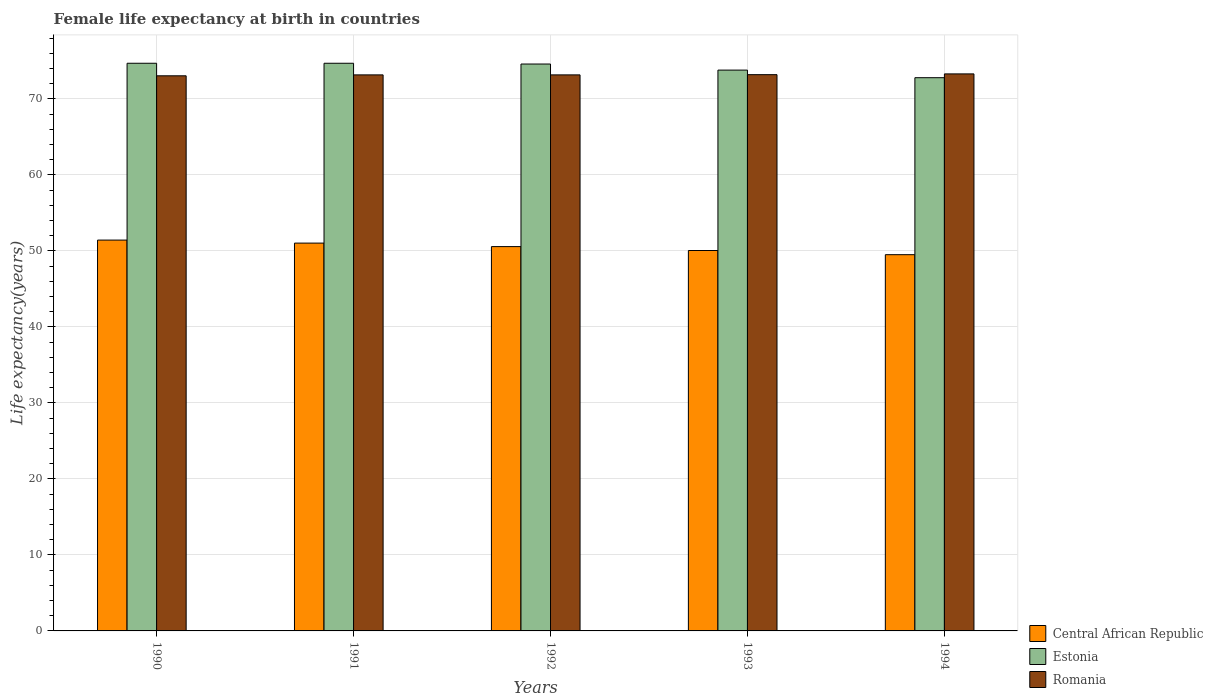Are the number of bars on each tick of the X-axis equal?
Ensure brevity in your answer.  Yes. How many bars are there on the 4th tick from the left?
Provide a short and direct response. 3. What is the label of the 3rd group of bars from the left?
Provide a succinct answer. 1992. What is the female life expectancy at birth in Central African Republic in 1993?
Offer a terse response. 50.06. Across all years, what is the maximum female life expectancy at birth in Central African Republic?
Keep it short and to the point. 51.43. Across all years, what is the minimum female life expectancy at birth in Central African Republic?
Provide a succinct answer. 49.51. What is the total female life expectancy at birth in Estonia in the graph?
Make the answer very short. 370.6. What is the difference between the female life expectancy at birth in Central African Republic in 1991 and that in 1993?
Your response must be concise. 0.97. What is the difference between the female life expectancy at birth in Estonia in 1992 and the female life expectancy at birth in Romania in 1991?
Make the answer very short. 1.43. What is the average female life expectancy at birth in Romania per year?
Offer a very short reply. 73.18. In the year 1993, what is the difference between the female life expectancy at birth in Estonia and female life expectancy at birth in Romania?
Your response must be concise. 0.6. What is the ratio of the female life expectancy at birth in Central African Republic in 1991 to that in 1994?
Offer a very short reply. 1.03. Is the difference between the female life expectancy at birth in Estonia in 1991 and 1992 greater than the difference between the female life expectancy at birth in Romania in 1991 and 1992?
Provide a succinct answer. Yes. What is the difference between the highest and the lowest female life expectancy at birth in Romania?
Your answer should be very brief. 0.25. In how many years, is the female life expectancy at birth in Central African Republic greater than the average female life expectancy at birth in Central African Republic taken over all years?
Offer a very short reply. 3. Is the sum of the female life expectancy at birth in Central African Republic in 1990 and 1992 greater than the maximum female life expectancy at birth in Estonia across all years?
Offer a very short reply. Yes. What does the 3rd bar from the left in 1994 represents?
Your answer should be very brief. Romania. What does the 1st bar from the right in 1990 represents?
Offer a very short reply. Romania. Are all the bars in the graph horizontal?
Your response must be concise. No. What is the difference between two consecutive major ticks on the Y-axis?
Your response must be concise. 10. Are the values on the major ticks of Y-axis written in scientific E-notation?
Your answer should be compact. No. Does the graph contain any zero values?
Keep it short and to the point. No. Does the graph contain grids?
Keep it short and to the point. Yes. Where does the legend appear in the graph?
Keep it short and to the point. Bottom right. How many legend labels are there?
Offer a terse response. 3. What is the title of the graph?
Provide a succinct answer. Female life expectancy at birth in countries. Does "Oman" appear as one of the legend labels in the graph?
Ensure brevity in your answer.  No. What is the label or title of the Y-axis?
Keep it short and to the point. Life expectancy(years). What is the Life expectancy(years) of Central African Republic in 1990?
Make the answer very short. 51.43. What is the Life expectancy(years) in Estonia in 1990?
Your answer should be compact. 74.7. What is the Life expectancy(years) of Romania in 1990?
Offer a terse response. 73.05. What is the Life expectancy(years) in Central African Republic in 1991?
Provide a succinct answer. 51.03. What is the Life expectancy(years) in Estonia in 1991?
Offer a terse response. 74.7. What is the Life expectancy(years) in Romania in 1991?
Ensure brevity in your answer.  73.17. What is the Life expectancy(years) of Central African Republic in 1992?
Offer a very short reply. 50.57. What is the Life expectancy(years) of Estonia in 1992?
Keep it short and to the point. 74.6. What is the Life expectancy(years) in Romania in 1992?
Provide a short and direct response. 73.17. What is the Life expectancy(years) in Central African Republic in 1993?
Your answer should be compact. 50.06. What is the Life expectancy(years) in Estonia in 1993?
Offer a terse response. 73.8. What is the Life expectancy(years) of Romania in 1993?
Keep it short and to the point. 73.2. What is the Life expectancy(years) of Central African Republic in 1994?
Offer a terse response. 49.51. What is the Life expectancy(years) in Estonia in 1994?
Your answer should be compact. 72.8. What is the Life expectancy(years) of Romania in 1994?
Provide a succinct answer. 73.3. Across all years, what is the maximum Life expectancy(years) of Central African Republic?
Make the answer very short. 51.43. Across all years, what is the maximum Life expectancy(years) in Estonia?
Keep it short and to the point. 74.7. Across all years, what is the maximum Life expectancy(years) in Romania?
Your response must be concise. 73.3. Across all years, what is the minimum Life expectancy(years) of Central African Republic?
Your answer should be very brief. 49.51. Across all years, what is the minimum Life expectancy(years) of Estonia?
Provide a succinct answer. 72.8. Across all years, what is the minimum Life expectancy(years) in Romania?
Your answer should be compact. 73.05. What is the total Life expectancy(years) in Central African Republic in the graph?
Keep it short and to the point. 252.61. What is the total Life expectancy(years) of Estonia in the graph?
Offer a very short reply. 370.6. What is the total Life expectancy(years) in Romania in the graph?
Your answer should be very brief. 365.89. What is the difference between the Life expectancy(years) in Central African Republic in 1990 and that in 1991?
Your response must be concise. 0.4. What is the difference between the Life expectancy(years) in Romania in 1990 and that in 1991?
Ensure brevity in your answer.  -0.12. What is the difference between the Life expectancy(years) of Central African Republic in 1990 and that in 1992?
Offer a very short reply. 0.86. What is the difference between the Life expectancy(years) of Romania in 1990 and that in 1992?
Provide a succinct answer. -0.12. What is the difference between the Life expectancy(years) of Central African Republic in 1990 and that in 1993?
Your answer should be compact. 1.37. What is the difference between the Life expectancy(years) of Estonia in 1990 and that in 1993?
Offer a very short reply. 0.9. What is the difference between the Life expectancy(years) of Central African Republic in 1990 and that in 1994?
Provide a short and direct response. 1.92. What is the difference between the Life expectancy(years) in Estonia in 1990 and that in 1994?
Make the answer very short. 1.9. What is the difference between the Life expectancy(years) of Romania in 1990 and that in 1994?
Your answer should be compact. -0.25. What is the difference between the Life expectancy(years) of Central African Republic in 1991 and that in 1992?
Offer a terse response. 0.46. What is the difference between the Life expectancy(years) in Estonia in 1991 and that in 1992?
Make the answer very short. 0.1. What is the difference between the Life expectancy(years) in Romania in 1991 and that in 1992?
Ensure brevity in your answer.  0. What is the difference between the Life expectancy(years) of Central African Republic in 1991 and that in 1993?
Your response must be concise. 0.97. What is the difference between the Life expectancy(years) in Romania in 1991 and that in 1993?
Your response must be concise. -0.03. What is the difference between the Life expectancy(years) in Central African Republic in 1991 and that in 1994?
Provide a short and direct response. 1.52. What is the difference between the Life expectancy(years) of Romania in 1991 and that in 1994?
Ensure brevity in your answer.  -0.13. What is the difference between the Life expectancy(years) of Central African Republic in 1992 and that in 1993?
Your response must be concise. 0.51. What is the difference between the Life expectancy(years) of Romania in 1992 and that in 1993?
Offer a terse response. -0.03. What is the difference between the Life expectancy(years) of Central African Republic in 1992 and that in 1994?
Offer a terse response. 1.06. What is the difference between the Life expectancy(years) of Romania in 1992 and that in 1994?
Offer a terse response. -0.13. What is the difference between the Life expectancy(years) of Central African Republic in 1993 and that in 1994?
Provide a short and direct response. 0.55. What is the difference between the Life expectancy(years) of Estonia in 1993 and that in 1994?
Make the answer very short. 1. What is the difference between the Life expectancy(years) in Romania in 1993 and that in 1994?
Offer a terse response. -0.1. What is the difference between the Life expectancy(years) of Central African Republic in 1990 and the Life expectancy(years) of Estonia in 1991?
Your answer should be very brief. -23.27. What is the difference between the Life expectancy(years) of Central African Republic in 1990 and the Life expectancy(years) of Romania in 1991?
Your response must be concise. -21.74. What is the difference between the Life expectancy(years) of Estonia in 1990 and the Life expectancy(years) of Romania in 1991?
Your answer should be compact. 1.53. What is the difference between the Life expectancy(years) of Central African Republic in 1990 and the Life expectancy(years) of Estonia in 1992?
Ensure brevity in your answer.  -23.17. What is the difference between the Life expectancy(years) in Central African Republic in 1990 and the Life expectancy(years) in Romania in 1992?
Make the answer very short. -21.74. What is the difference between the Life expectancy(years) in Estonia in 1990 and the Life expectancy(years) in Romania in 1992?
Your response must be concise. 1.53. What is the difference between the Life expectancy(years) in Central African Republic in 1990 and the Life expectancy(years) in Estonia in 1993?
Your answer should be very brief. -22.37. What is the difference between the Life expectancy(years) in Central African Republic in 1990 and the Life expectancy(years) in Romania in 1993?
Your answer should be compact. -21.77. What is the difference between the Life expectancy(years) in Estonia in 1990 and the Life expectancy(years) in Romania in 1993?
Give a very brief answer. 1.5. What is the difference between the Life expectancy(years) of Central African Republic in 1990 and the Life expectancy(years) of Estonia in 1994?
Ensure brevity in your answer.  -21.37. What is the difference between the Life expectancy(years) in Central African Republic in 1990 and the Life expectancy(years) in Romania in 1994?
Provide a succinct answer. -21.87. What is the difference between the Life expectancy(years) in Estonia in 1990 and the Life expectancy(years) in Romania in 1994?
Ensure brevity in your answer.  1.4. What is the difference between the Life expectancy(years) in Central African Republic in 1991 and the Life expectancy(years) in Estonia in 1992?
Ensure brevity in your answer.  -23.57. What is the difference between the Life expectancy(years) of Central African Republic in 1991 and the Life expectancy(years) of Romania in 1992?
Offer a terse response. -22.14. What is the difference between the Life expectancy(years) in Estonia in 1991 and the Life expectancy(years) in Romania in 1992?
Make the answer very short. 1.53. What is the difference between the Life expectancy(years) in Central African Republic in 1991 and the Life expectancy(years) in Estonia in 1993?
Ensure brevity in your answer.  -22.77. What is the difference between the Life expectancy(years) in Central African Republic in 1991 and the Life expectancy(years) in Romania in 1993?
Provide a short and direct response. -22.17. What is the difference between the Life expectancy(years) of Estonia in 1991 and the Life expectancy(years) of Romania in 1993?
Provide a succinct answer. 1.5. What is the difference between the Life expectancy(years) of Central African Republic in 1991 and the Life expectancy(years) of Estonia in 1994?
Provide a succinct answer. -21.77. What is the difference between the Life expectancy(years) of Central African Republic in 1991 and the Life expectancy(years) of Romania in 1994?
Make the answer very short. -22.27. What is the difference between the Life expectancy(years) of Central African Republic in 1992 and the Life expectancy(years) of Estonia in 1993?
Ensure brevity in your answer.  -23.23. What is the difference between the Life expectancy(years) in Central African Republic in 1992 and the Life expectancy(years) in Romania in 1993?
Your response must be concise. -22.63. What is the difference between the Life expectancy(years) of Estonia in 1992 and the Life expectancy(years) of Romania in 1993?
Give a very brief answer. 1.4. What is the difference between the Life expectancy(years) of Central African Republic in 1992 and the Life expectancy(years) of Estonia in 1994?
Offer a terse response. -22.23. What is the difference between the Life expectancy(years) of Central African Republic in 1992 and the Life expectancy(years) of Romania in 1994?
Keep it short and to the point. -22.73. What is the difference between the Life expectancy(years) in Central African Republic in 1993 and the Life expectancy(years) in Estonia in 1994?
Provide a succinct answer. -22.74. What is the difference between the Life expectancy(years) in Central African Republic in 1993 and the Life expectancy(years) in Romania in 1994?
Offer a very short reply. -23.24. What is the average Life expectancy(years) of Central African Republic per year?
Your response must be concise. 50.52. What is the average Life expectancy(years) in Estonia per year?
Offer a terse response. 74.12. What is the average Life expectancy(years) of Romania per year?
Give a very brief answer. 73.18. In the year 1990, what is the difference between the Life expectancy(years) of Central African Republic and Life expectancy(years) of Estonia?
Offer a very short reply. -23.27. In the year 1990, what is the difference between the Life expectancy(years) in Central African Republic and Life expectancy(years) in Romania?
Ensure brevity in your answer.  -21.62. In the year 1990, what is the difference between the Life expectancy(years) of Estonia and Life expectancy(years) of Romania?
Ensure brevity in your answer.  1.65. In the year 1991, what is the difference between the Life expectancy(years) of Central African Republic and Life expectancy(years) of Estonia?
Your answer should be very brief. -23.67. In the year 1991, what is the difference between the Life expectancy(years) of Central African Republic and Life expectancy(years) of Romania?
Ensure brevity in your answer.  -22.14. In the year 1991, what is the difference between the Life expectancy(years) of Estonia and Life expectancy(years) of Romania?
Ensure brevity in your answer.  1.53. In the year 1992, what is the difference between the Life expectancy(years) in Central African Republic and Life expectancy(years) in Estonia?
Keep it short and to the point. -24.03. In the year 1992, what is the difference between the Life expectancy(years) in Central African Republic and Life expectancy(years) in Romania?
Make the answer very short. -22.6. In the year 1992, what is the difference between the Life expectancy(years) in Estonia and Life expectancy(years) in Romania?
Provide a short and direct response. 1.43. In the year 1993, what is the difference between the Life expectancy(years) in Central African Republic and Life expectancy(years) in Estonia?
Ensure brevity in your answer.  -23.74. In the year 1993, what is the difference between the Life expectancy(years) of Central African Republic and Life expectancy(years) of Romania?
Your response must be concise. -23.14. In the year 1993, what is the difference between the Life expectancy(years) in Estonia and Life expectancy(years) in Romania?
Provide a succinct answer. 0.6. In the year 1994, what is the difference between the Life expectancy(years) in Central African Republic and Life expectancy(years) in Estonia?
Offer a terse response. -23.29. In the year 1994, what is the difference between the Life expectancy(years) of Central African Republic and Life expectancy(years) of Romania?
Your answer should be very brief. -23.79. What is the ratio of the Life expectancy(years) in Romania in 1990 to that in 1991?
Keep it short and to the point. 1. What is the ratio of the Life expectancy(years) of Central African Republic in 1990 to that in 1992?
Your answer should be very brief. 1.02. What is the ratio of the Life expectancy(years) of Estonia in 1990 to that in 1992?
Provide a short and direct response. 1. What is the ratio of the Life expectancy(years) in Romania in 1990 to that in 1992?
Your answer should be compact. 1. What is the ratio of the Life expectancy(years) of Central African Republic in 1990 to that in 1993?
Ensure brevity in your answer.  1.03. What is the ratio of the Life expectancy(years) of Estonia in 1990 to that in 1993?
Ensure brevity in your answer.  1.01. What is the ratio of the Life expectancy(years) in Romania in 1990 to that in 1993?
Provide a succinct answer. 1. What is the ratio of the Life expectancy(years) in Central African Republic in 1990 to that in 1994?
Your answer should be compact. 1.04. What is the ratio of the Life expectancy(years) of Estonia in 1990 to that in 1994?
Ensure brevity in your answer.  1.03. What is the ratio of the Life expectancy(years) of Romania in 1990 to that in 1994?
Your response must be concise. 1. What is the ratio of the Life expectancy(years) of Central African Republic in 1991 to that in 1992?
Give a very brief answer. 1.01. What is the ratio of the Life expectancy(years) of Central African Republic in 1991 to that in 1993?
Your answer should be very brief. 1.02. What is the ratio of the Life expectancy(years) of Estonia in 1991 to that in 1993?
Your response must be concise. 1.01. What is the ratio of the Life expectancy(years) in Central African Republic in 1991 to that in 1994?
Offer a very short reply. 1.03. What is the ratio of the Life expectancy(years) in Estonia in 1991 to that in 1994?
Provide a short and direct response. 1.03. What is the ratio of the Life expectancy(years) in Romania in 1991 to that in 1994?
Ensure brevity in your answer.  1. What is the ratio of the Life expectancy(years) of Central African Republic in 1992 to that in 1993?
Offer a very short reply. 1.01. What is the ratio of the Life expectancy(years) of Estonia in 1992 to that in 1993?
Ensure brevity in your answer.  1.01. What is the ratio of the Life expectancy(years) of Central African Republic in 1992 to that in 1994?
Ensure brevity in your answer.  1.02. What is the ratio of the Life expectancy(years) of Estonia in 1992 to that in 1994?
Provide a short and direct response. 1.02. What is the ratio of the Life expectancy(years) of Romania in 1992 to that in 1994?
Offer a terse response. 1. What is the ratio of the Life expectancy(years) of Central African Republic in 1993 to that in 1994?
Provide a succinct answer. 1.01. What is the ratio of the Life expectancy(years) in Estonia in 1993 to that in 1994?
Ensure brevity in your answer.  1.01. What is the difference between the highest and the second highest Life expectancy(years) in Central African Republic?
Your answer should be compact. 0.4. What is the difference between the highest and the second highest Life expectancy(years) of Estonia?
Offer a very short reply. 0. What is the difference between the highest and the lowest Life expectancy(years) of Central African Republic?
Provide a succinct answer. 1.92. What is the difference between the highest and the lowest Life expectancy(years) of Romania?
Your answer should be compact. 0.25. 